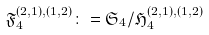<formula> <loc_0><loc_0><loc_500><loc_500>\mathfrak { F } _ { 4 } ^ { ( 2 , 1 ) , ( 1 , 2 ) } \colon = \mathfrak { S } _ { 4 } / \mathfrak { H } _ { 4 } ^ { ( 2 , 1 ) , ( 1 , 2 ) }</formula> 